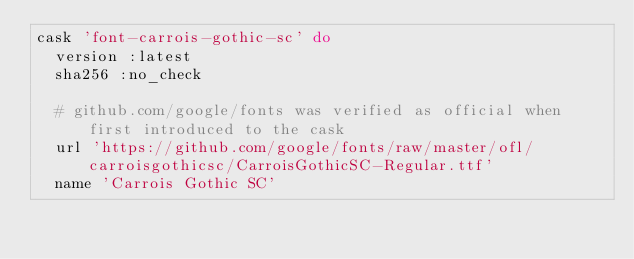Convert code to text. <code><loc_0><loc_0><loc_500><loc_500><_Ruby_>cask 'font-carrois-gothic-sc' do
  version :latest
  sha256 :no_check

  # github.com/google/fonts was verified as official when first introduced to the cask
  url 'https://github.com/google/fonts/raw/master/ofl/carroisgothicsc/CarroisGothicSC-Regular.ttf'
  name 'Carrois Gothic SC'</code> 